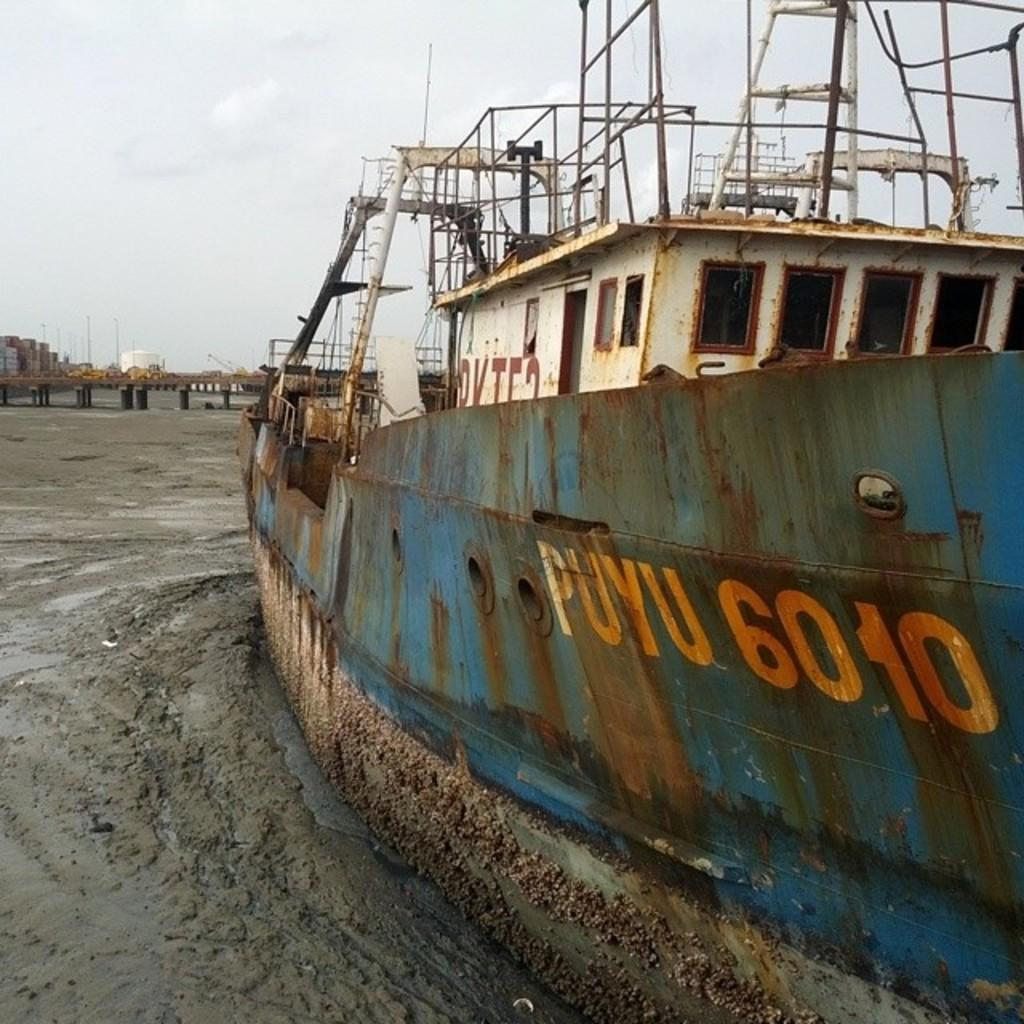What is located on the mud in the image? There is a boat on the mud in the image. What structure can be seen near the boat? There is a bridge or a pier in the image. What type of man-made structures are visible in the image? There are buildings in the image. What can be seen in the background of the image? The sky is visible in the background of the image. What leaf is causing the destruction of the buildings in the image? There is no leaf present in the image, and no destruction of buildings is depicted. 